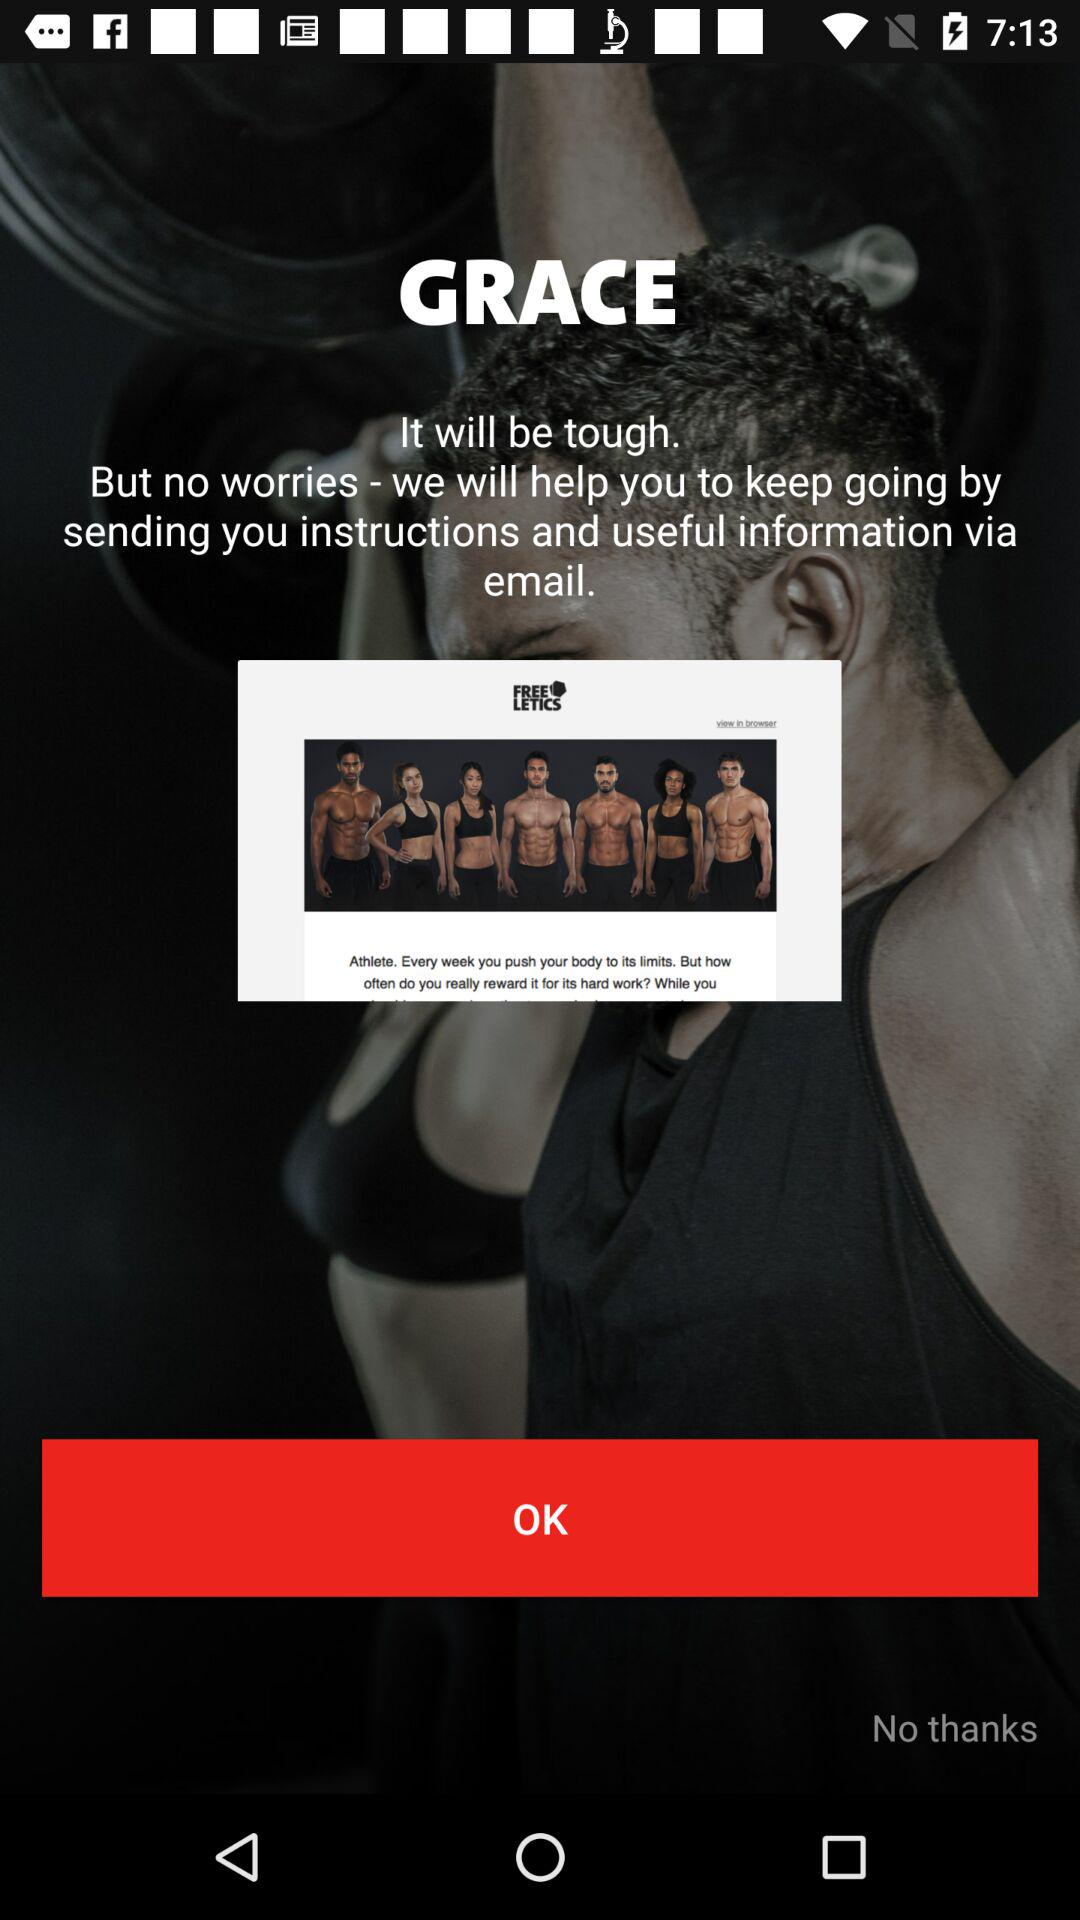How many CTAs are there in this screenshot?
Answer the question using a single word or phrase. 2 